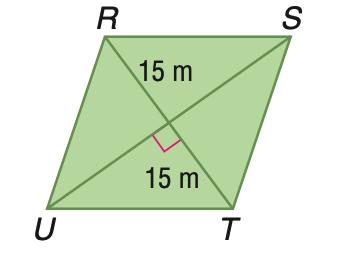Answer the mathemtical geometry problem and directly provide the correct option letter.
Question: Rhombus R S T U has an area of 675 square meters. Find S U.
Choices: A: 22.5 B: 25.98 C: 30 D: 45 D 